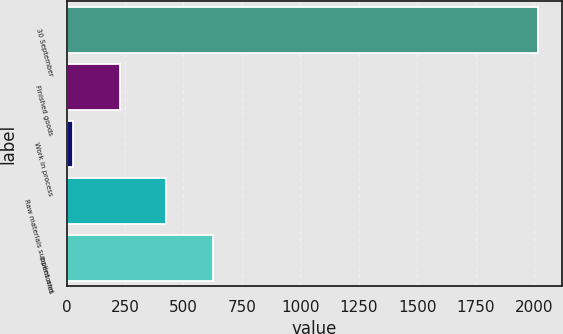Convert chart to OTSL. <chart><loc_0><loc_0><loc_500><loc_500><bar_chart><fcel>30 September<fcel>Finished goods<fcel>Work in process<fcel>Raw materials supplies and<fcel>Inventories<nl><fcel>2019<fcel>226.65<fcel>27.5<fcel>425.8<fcel>624.95<nl></chart> 